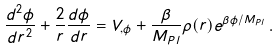<formula> <loc_0><loc_0><loc_500><loc_500>\frac { d ^ { 2 } \phi } { d r ^ { 2 } } + \frac { 2 } { r } \frac { d \phi } { d r } = V _ { , \phi } + \frac { \beta } { M _ { P l } } \rho ( r ) e ^ { \beta \phi / M _ { P l } } \, .</formula> 